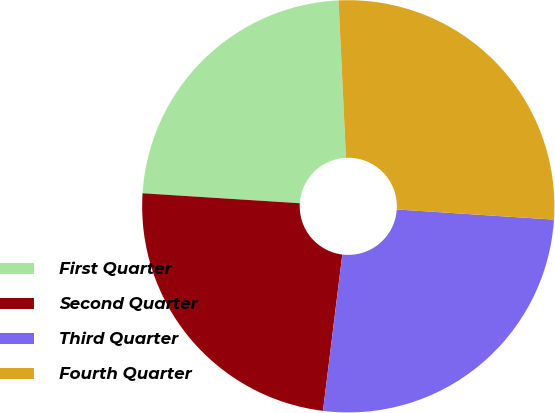Convert chart. <chart><loc_0><loc_0><loc_500><loc_500><pie_chart><fcel>First Quarter<fcel>Second Quarter<fcel>Third Quarter<fcel>Fourth Quarter<nl><fcel>23.24%<fcel>24.05%<fcel>25.93%<fcel>26.78%<nl></chart> 